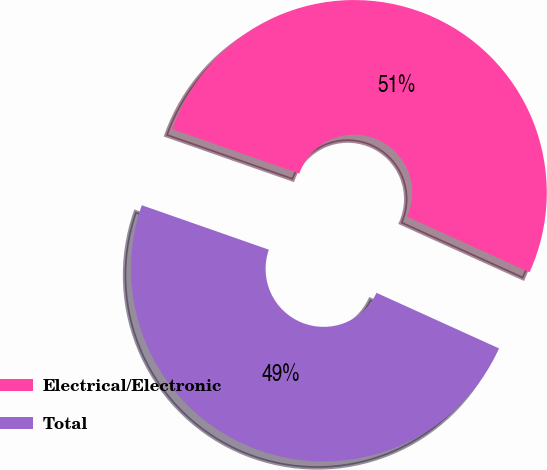Convert chart to OTSL. <chart><loc_0><loc_0><loc_500><loc_500><pie_chart><fcel>Electrical/Electronic<fcel>Total<nl><fcel>51.42%<fcel>48.58%<nl></chart> 